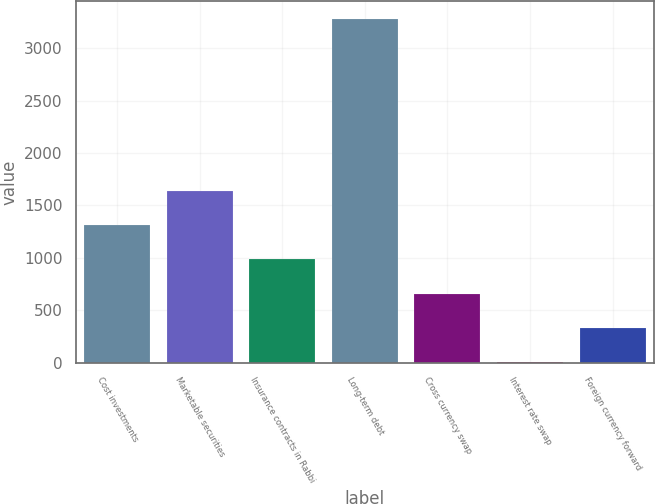<chart> <loc_0><loc_0><loc_500><loc_500><bar_chart><fcel>Cost investments<fcel>Marketable securities<fcel>Insurance contracts in Rabbi<fcel>Long-term debt<fcel>Cross currency swap<fcel>Interest rate swap<fcel>Foreign currency forward<nl><fcel>1313.4<fcel>1641.5<fcel>985.3<fcel>3282<fcel>657.2<fcel>1<fcel>329.1<nl></chart> 